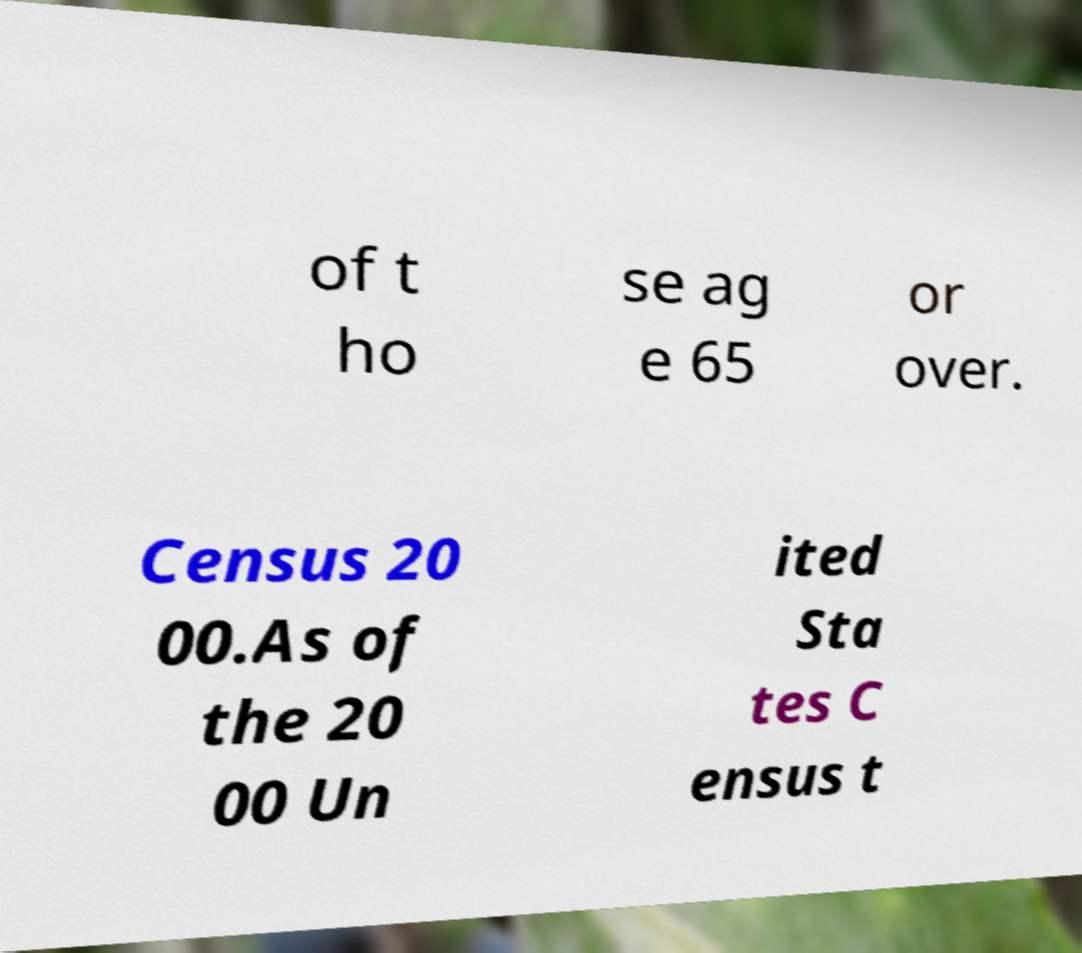For documentation purposes, I need the text within this image transcribed. Could you provide that? of t ho se ag e 65 or over. Census 20 00.As of the 20 00 Un ited Sta tes C ensus t 